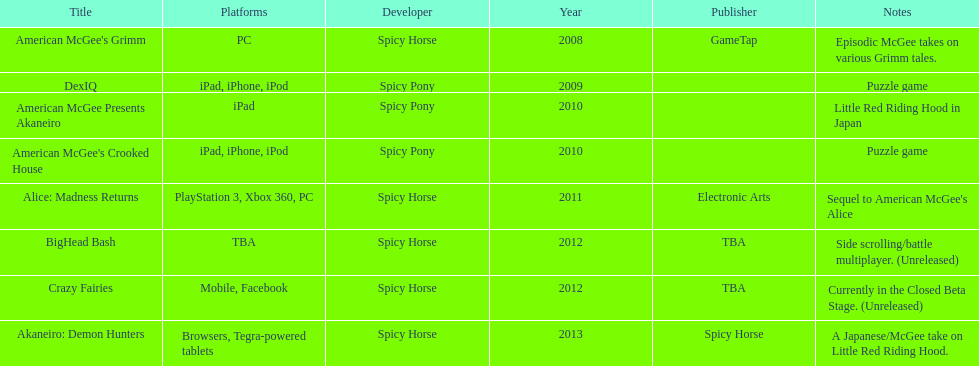What is the first title on this chart? American McGee's Grimm. 